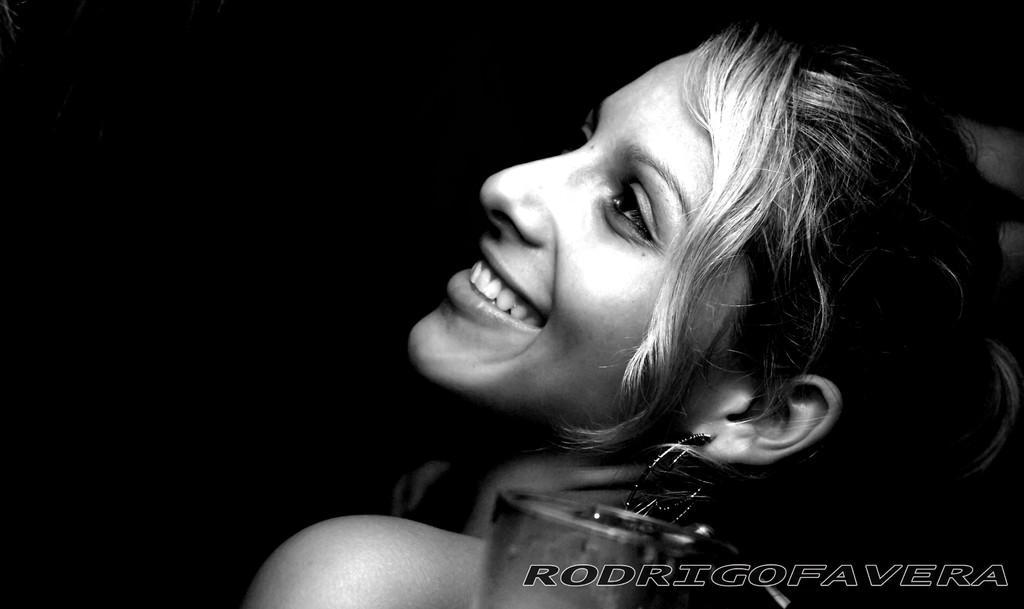Could you give a brief overview of what you see in this image? It is a black and white image. In this image, a woman is smiling and earring. At the bottom, we can see glass object. Right side bottom of the image, we can see watermark. Background we can see the dark view. 